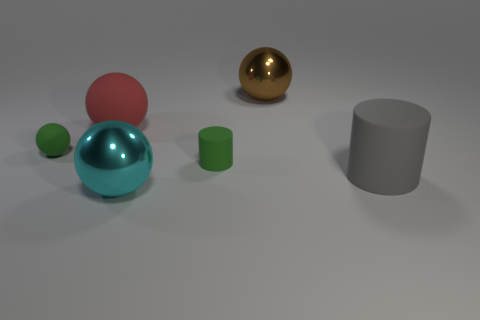What time of day or lighting setting does the image suggest? The lighting in the image does not suggest a specific time of day, as it appears to be a controlled, indoor lighting situation with a neutral background. The soft shadows cast by the objects imply an overhead diffuse light source, such as studio lighting commonly used in photography or rendering. 